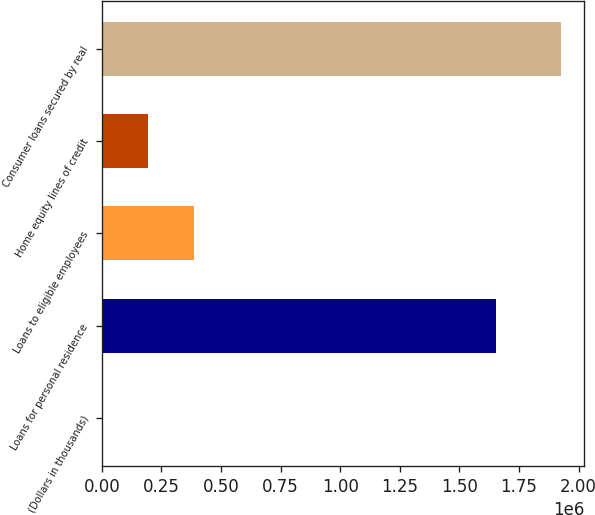<chart> <loc_0><loc_0><loc_500><loc_500><bar_chart><fcel>(Dollars in thousands)<fcel>Loans for personal residence<fcel>Loans to eligible employees<fcel>Home equity lines of credit<fcel>Consumer loans secured by real<nl><fcel>2016<fcel>1.65535e+06<fcel>387006<fcel>194511<fcel>1.92697e+06<nl></chart> 